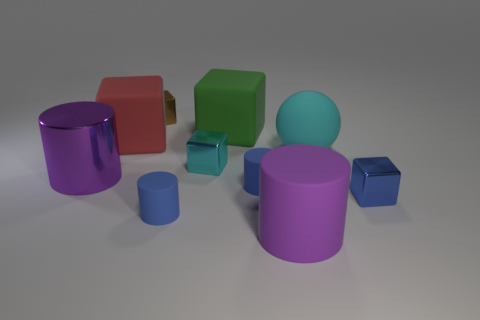Is the number of cyan spheres behind the large green object greater than the number of matte spheres?
Provide a short and direct response. No. What number of metal cubes have the same color as the ball?
Your answer should be very brief. 1. What number of other things are there of the same color as the large sphere?
Your answer should be very brief. 1. Are there more large cyan balls than large red balls?
Provide a succinct answer. Yes. What is the material of the small cyan cube?
Keep it short and to the point. Metal. Do the matte cylinder left of the green cube and the small cyan block have the same size?
Provide a short and direct response. Yes. How big is the rubber block to the left of the large green matte cube?
Offer a very short reply. Large. Are there any other things that are made of the same material as the small brown object?
Your answer should be compact. Yes. What number of tiny rubber cylinders are there?
Your answer should be compact. 2. Is the color of the ball the same as the shiny cylinder?
Ensure brevity in your answer.  No. 